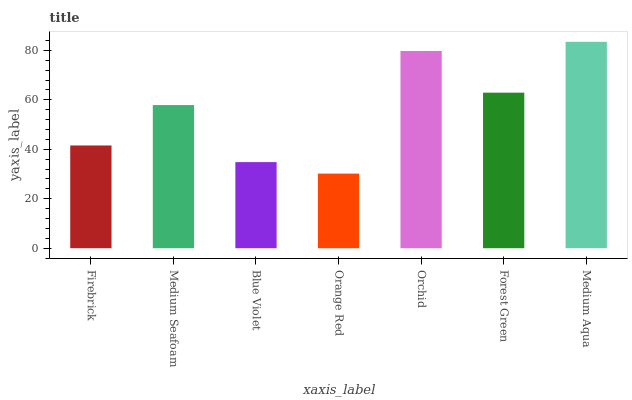Is Medium Seafoam the minimum?
Answer yes or no. No. Is Medium Seafoam the maximum?
Answer yes or no. No. Is Medium Seafoam greater than Firebrick?
Answer yes or no. Yes. Is Firebrick less than Medium Seafoam?
Answer yes or no. Yes. Is Firebrick greater than Medium Seafoam?
Answer yes or no. No. Is Medium Seafoam less than Firebrick?
Answer yes or no. No. Is Medium Seafoam the high median?
Answer yes or no. Yes. Is Medium Seafoam the low median?
Answer yes or no. Yes. Is Medium Aqua the high median?
Answer yes or no. No. Is Medium Aqua the low median?
Answer yes or no. No. 